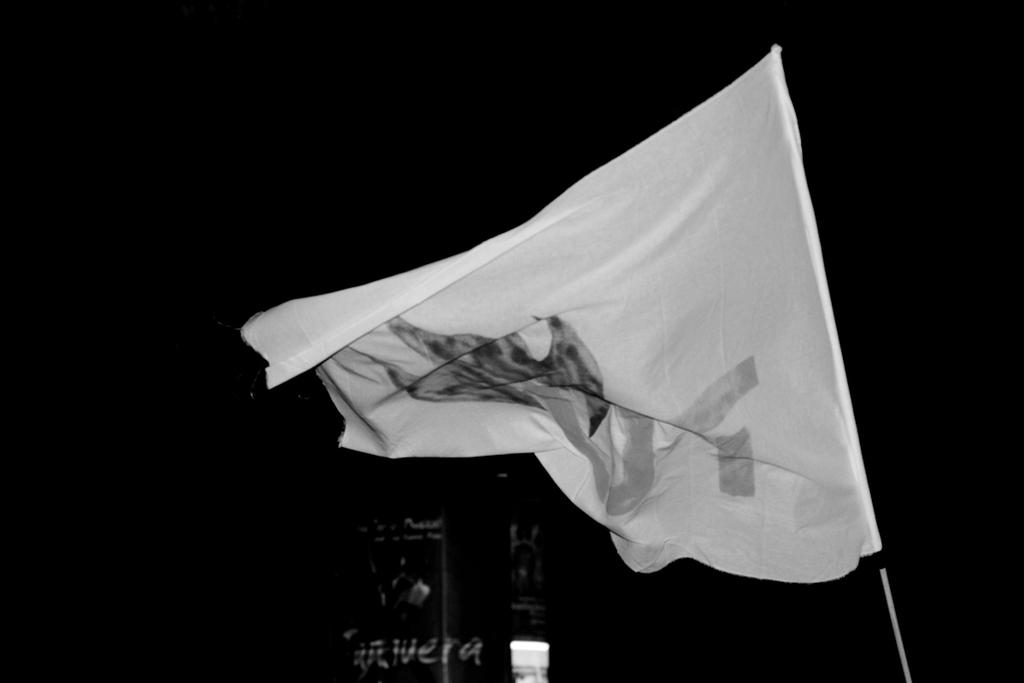What is the color scheme of the image? The image is black and white. What can be seen in the image besides the black and white color scheme? There is a flag and text in the image. What is the background color of the image? The background of the image is black. How many tomatoes are hanging from the flag in the image? There are no tomatoes present in the image. What type of man can be seen walking in the background of the image? There is no man or background visible in the image, as it is a black and white image with a flag and text. 